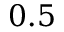<formula> <loc_0><loc_0><loc_500><loc_500>0 . 5</formula> 